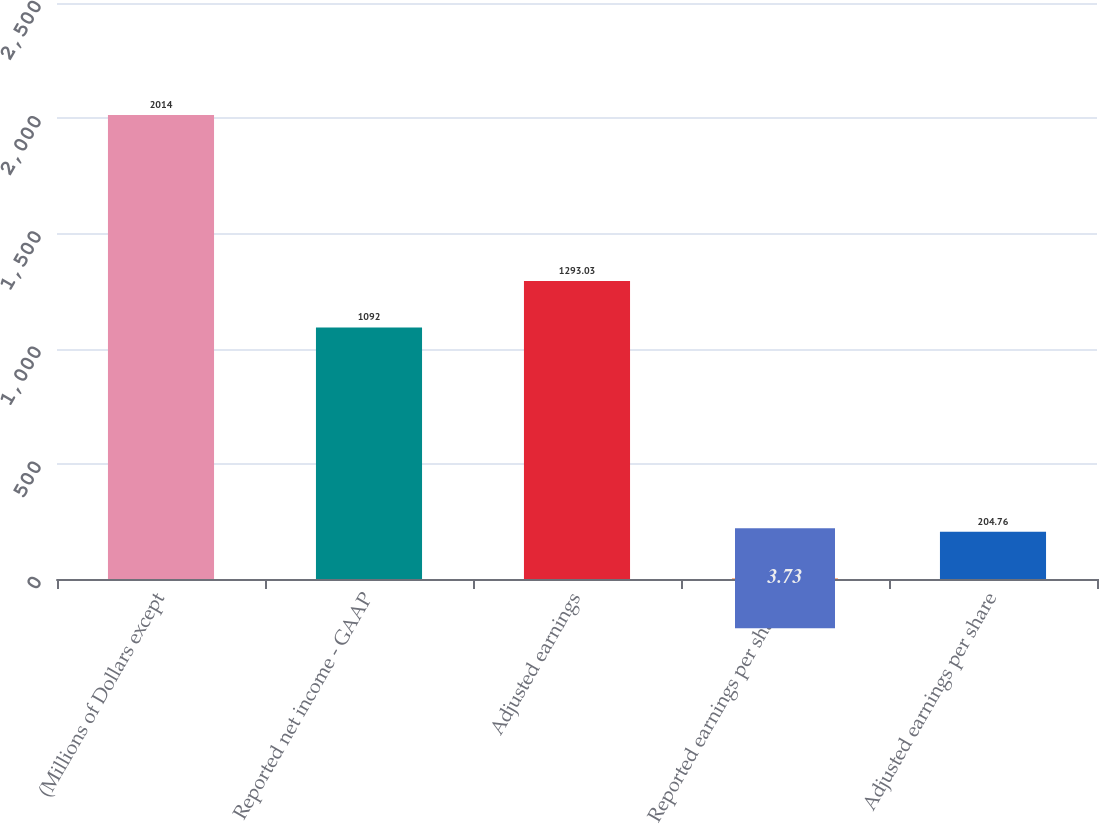Convert chart to OTSL. <chart><loc_0><loc_0><loc_500><loc_500><bar_chart><fcel>(Millions of Dollars except<fcel>Reported net income - GAAP<fcel>Adjusted earnings<fcel>Reported earnings per share -<fcel>Adjusted earnings per share<nl><fcel>2014<fcel>1092<fcel>1293.03<fcel>3.73<fcel>204.76<nl></chart> 